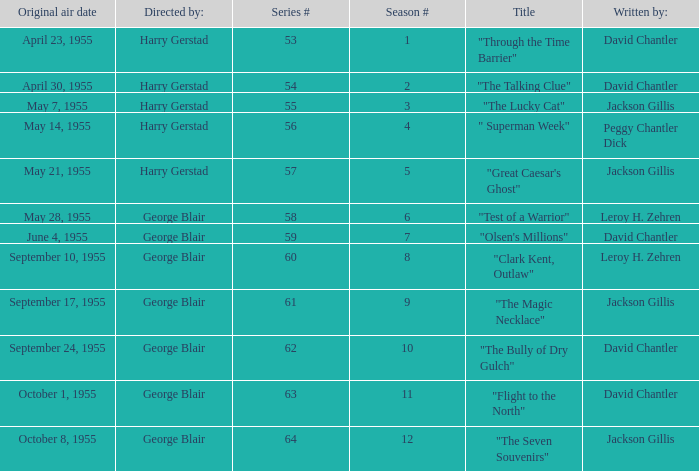Who was "The Magic Necklace" written by? Jackson Gillis. 